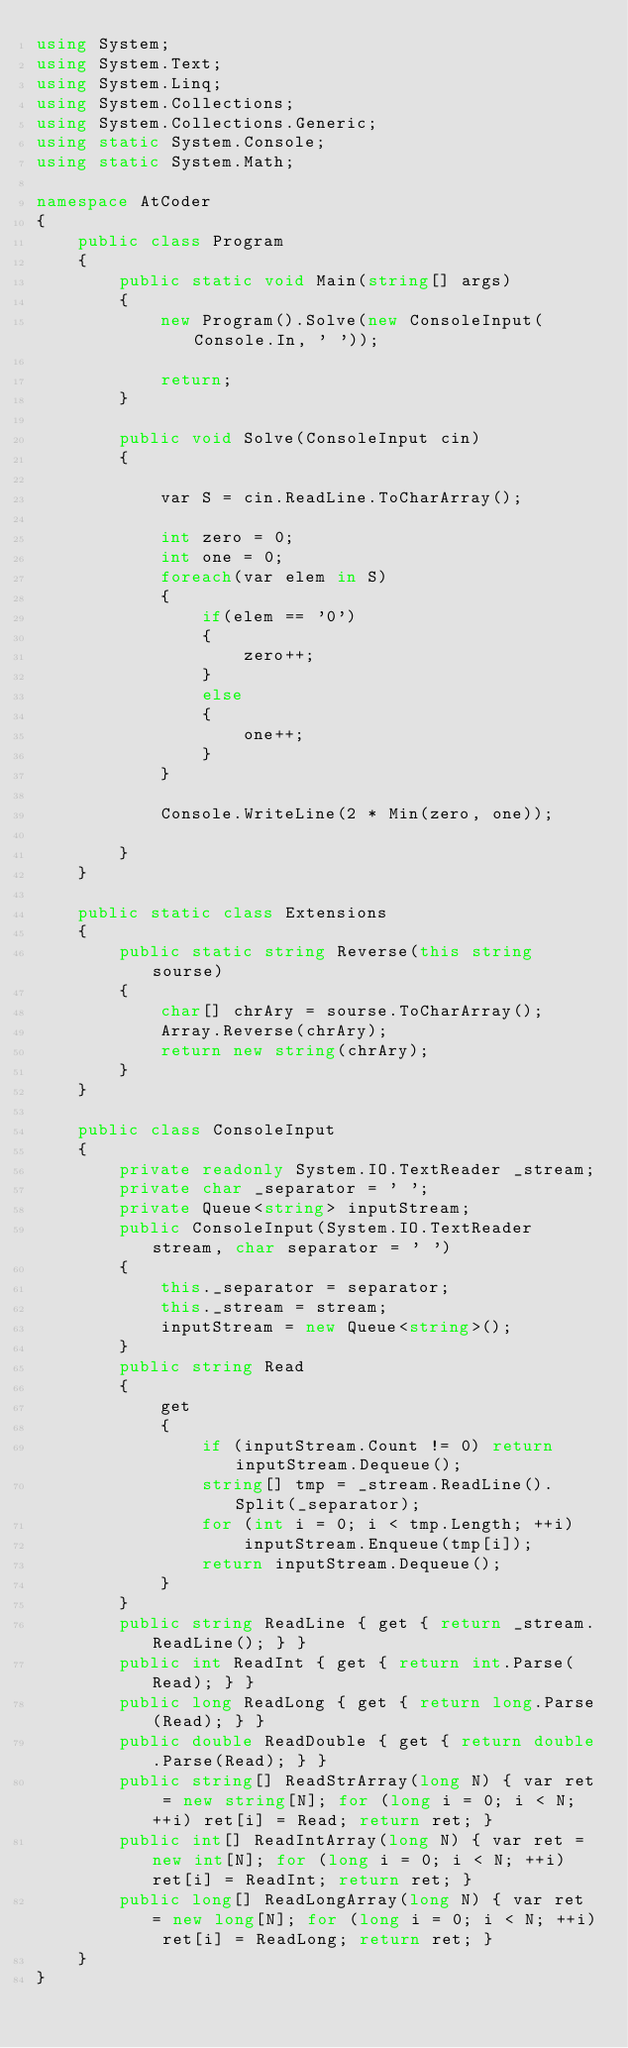Convert code to text. <code><loc_0><loc_0><loc_500><loc_500><_C#_>using System;
using System.Text;
using System.Linq;
using System.Collections;
using System.Collections.Generic;
using static System.Console;
using static System.Math;

namespace AtCoder
{
    public class Program
    {
        public static void Main(string[] args)
        {
            new Program().Solve(new ConsoleInput(Console.In, ' '));

            return;
        }

        public void Solve(ConsoleInput cin)
        {

            var S = cin.ReadLine.ToCharArray();

            int zero = 0;
            int one = 0;
            foreach(var elem in S)
            {
                if(elem == '0')
                {
                    zero++;
                }
                else
                {
                    one++;
                }
            }

            Console.WriteLine(2 * Min(zero, one));

        }
    }

    public static class Extensions
    {
        public static string Reverse(this string sourse)
        {
            char[] chrAry = sourse.ToCharArray();
            Array.Reverse(chrAry);
            return new string(chrAry);
        }
    }

    public class ConsoleInput
    {
        private readonly System.IO.TextReader _stream;
        private char _separator = ' ';
        private Queue<string> inputStream;
        public ConsoleInput(System.IO.TextReader stream, char separator = ' ')
        {
            this._separator = separator;
            this._stream = stream;
            inputStream = new Queue<string>();
        }
        public string Read
        {
            get
            {
                if (inputStream.Count != 0) return inputStream.Dequeue();
                string[] tmp = _stream.ReadLine().Split(_separator);
                for (int i = 0; i < tmp.Length; ++i)
                    inputStream.Enqueue(tmp[i]);
                return inputStream.Dequeue();
            }
        }
        public string ReadLine { get { return _stream.ReadLine(); } }
        public int ReadInt { get { return int.Parse(Read); } }
        public long ReadLong { get { return long.Parse(Read); } }
        public double ReadDouble { get { return double.Parse(Read); } }
        public string[] ReadStrArray(long N) { var ret = new string[N]; for (long i = 0; i < N; ++i) ret[i] = Read; return ret; }
        public int[] ReadIntArray(long N) { var ret = new int[N]; for (long i = 0; i < N; ++i) ret[i] = ReadInt; return ret; }
        public long[] ReadLongArray(long N) { var ret = new long[N]; for (long i = 0; i < N; ++i) ret[i] = ReadLong; return ret; }
    }
}
</code> 